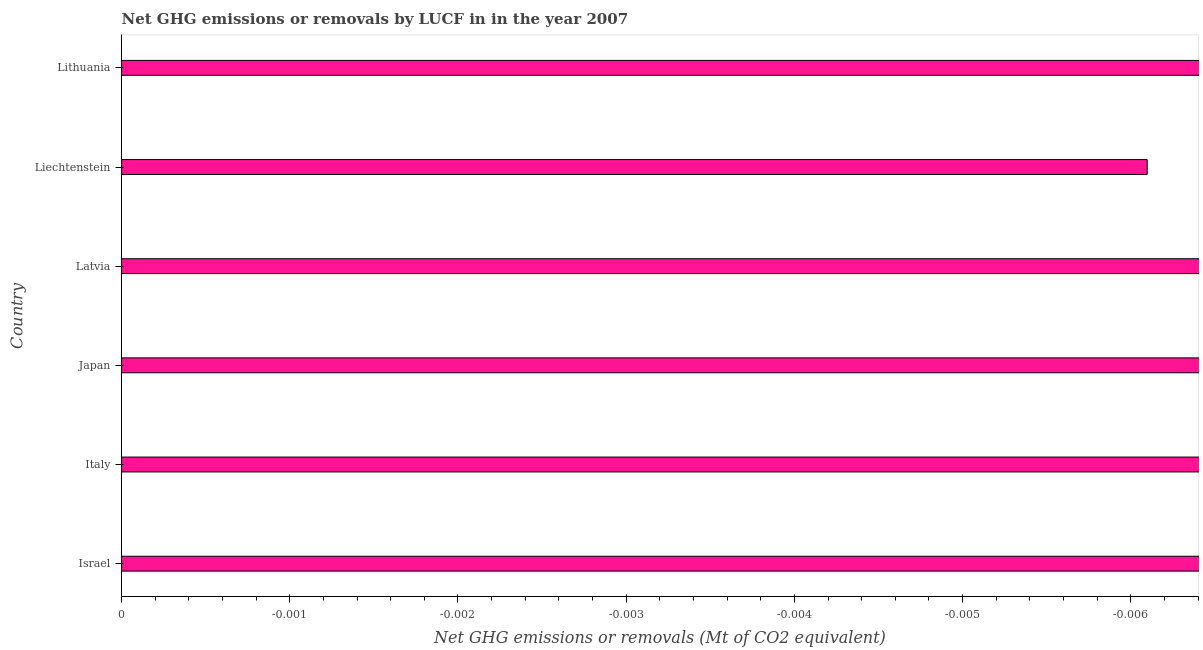What is the title of the graph?
Ensure brevity in your answer.  Net GHG emissions or removals by LUCF in in the year 2007. What is the label or title of the X-axis?
Your response must be concise. Net GHG emissions or removals (Mt of CO2 equivalent). What is the ghg net emissions or removals in Liechtenstein?
Make the answer very short. 0. Across all countries, what is the minimum ghg net emissions or removals?
Your answer should be compact. 0. What is the sum of the ghg net emissions or removals?
Offer a very short reply. 0. In how many countries, is the ghg net emissions or removals greater than the average ghg net emissions or removals taken over all countries?
Your response must be concise. 0. How many bars are there?
Ensure brevity in your answer.  0. How many countries are there in the graph?
Provide a succinct answer. 6. What is the difference between two consecutive major ticks on the X-axis?
Ensure brevity in your answer.  0. What is the Net GHG emissions or removals (Mt of CO2 equivalent) of Latvia?
Give a very brief answer. 0. What is the Net GHG emissions or removals (Mt of CO2 equivalent) in Liechtenstein?
Provide a short and direct response. 0. 